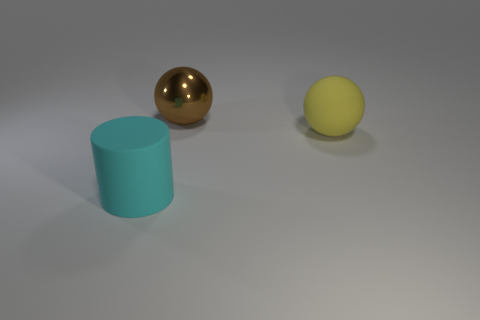Add 3 large rubber cylinders. How many objects exist? 6 Subtract 2 balls. How many balls are left? 0 Subtract all spheres. How many objects are left? 1 Subtract all brown rubber things. Subtract all yellow rubber things. How many objects are left? 2 Add 3 large matte spheres. How many large matte spheres are left? 4 Add 1 big green things. How many big green things exist? 1 Subtract 0 green balls. How many objects are left? 3 Subtract all brown balls. Subtract all brown cylinders. How many balls are left? 1 Subtract all purple blocks. How many yellow spheres are left? 1 